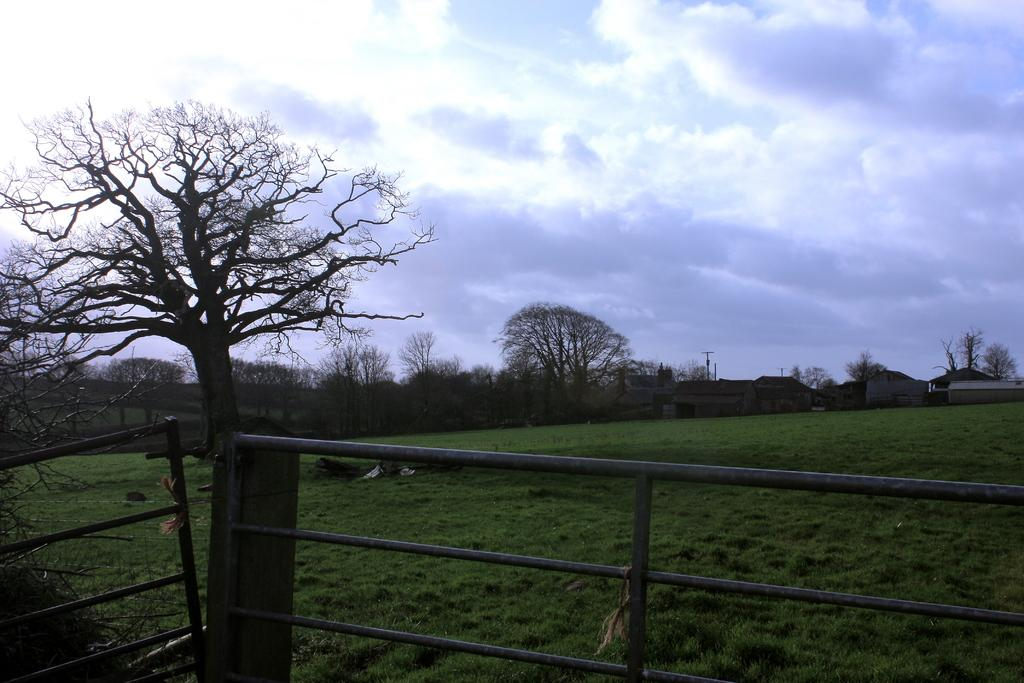What type of fence is visible in the image? There is an iron fence in the image. What can be seen in the background of the image? There are trees and buildings in the background of the image. What is on the ground in the image? There is grass on the ground in the image. What is visible in the sky in the image? There are clouds in the sky in the image. What type of marble is used to create the rhythm in the image? There is no marble or rhythm present in the image. 